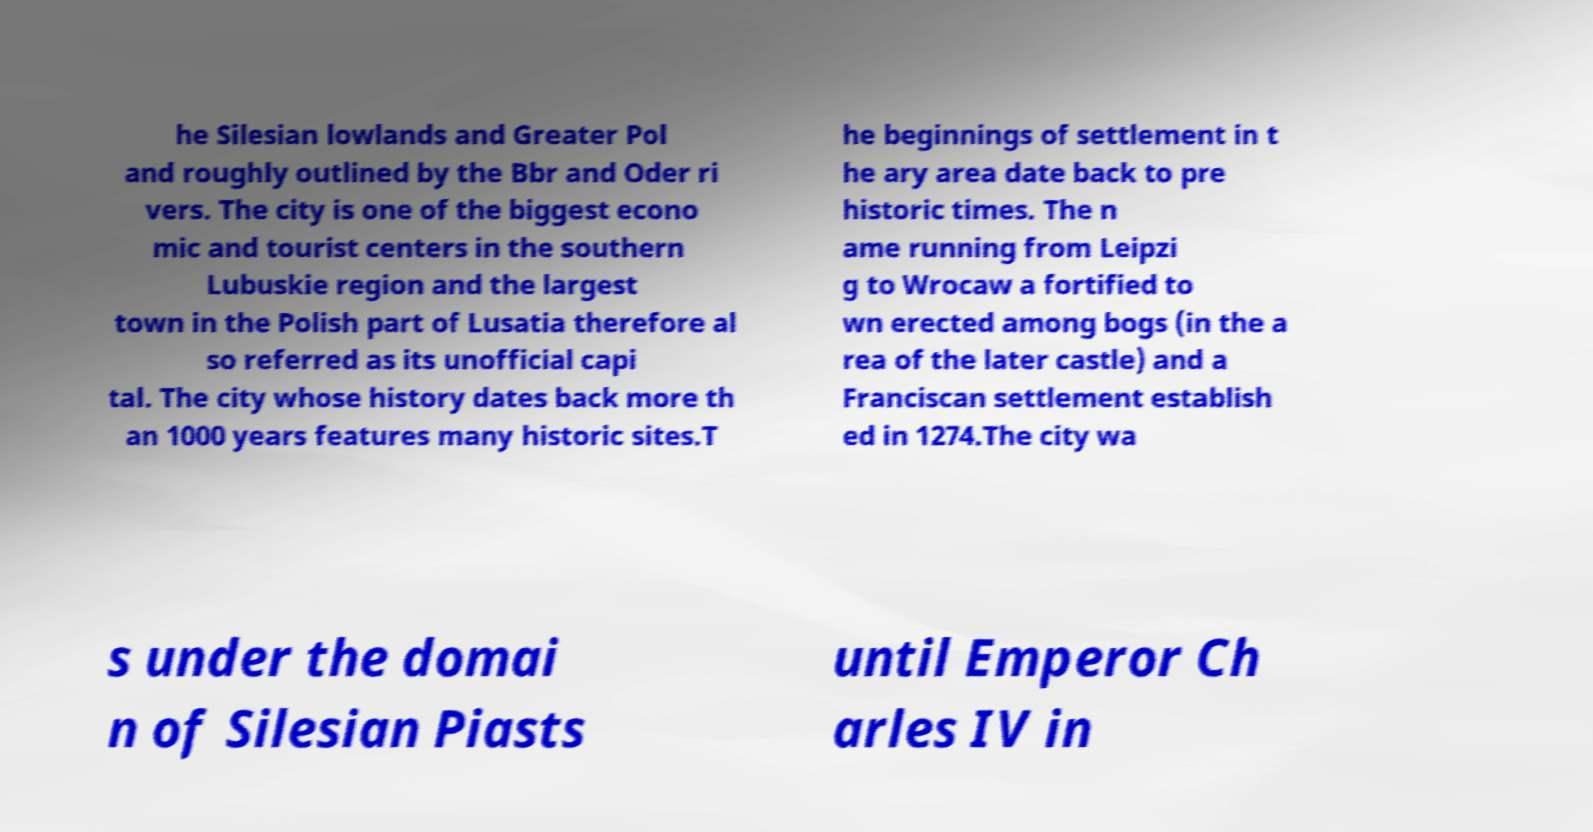Could you extract and type out the text from this image? he Silesian lowlands and Greater Pol and roughly outlined by the Bbr and Oder ri vers. The city is one of the biggest econo mic and tourist centers in the southern Lubuskie region and the largest town in the Polish part of Lusatia therefore al so referred as its unofficial capi tal. The city whose history dates back more th an 1000 years features many historic sites.T he beginnings of settlement in t he ary area date back to pre historic times. The n ame running from Leipzi g to Wrocaw a fortified to wn erected among bogs (in the a rea of the later castle) and a Franciscan settlement establish ed in 1274.The city wa s under the domai n of Silesian Piasts until Emperor Ch arles IV in 